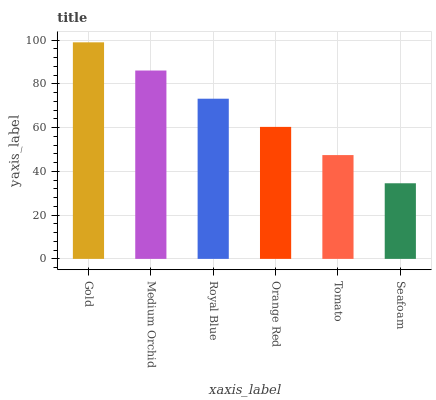Is Seafoam the minimum?
Answer yes or no. Yes. Is Gold the maximum?
Answer yes or no. Yes. Is Medium Orchid the minimum?
Answer yes or no. No. Is Medium Orchid the maximum?
Answer yes or no. No. Is Gold greater than Medium Orchid?
Answer yes or no. Yes. Is Medium Orchid less than Gold?
Answer yes or no. Yes. Is Medium Orchid greater than Gold?
Answer yes or no. No. Is Gold less than Medium Orchid?
Answer yes or no. No. Is Royal Blue the high median?
Answer yes or no. Yes. Is Orange Red the low median?
Answer yes or no. Yes. Is Seafoam the high median?
Answer yes or no. No. Is Medium Orchid the low median?
Answer yes or no. No. 